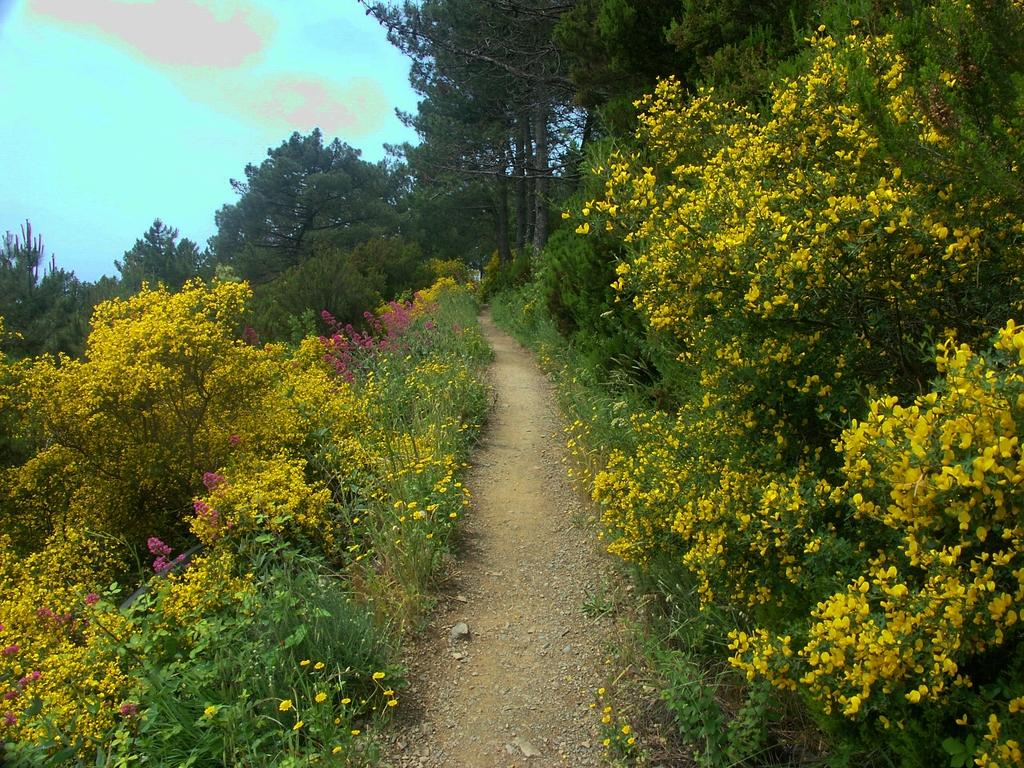What can be seen in the sky in the image? The sky with clouds is visible in the image. What type of vegetation is present in the image? There are trees, plants, bushes, and shrubs visible in the image. What kind of pathway is in the image? A walkway is in the image. What type of toy is being used to capture the image? There is no toy present in the image, and the image was not captured using a toy. 